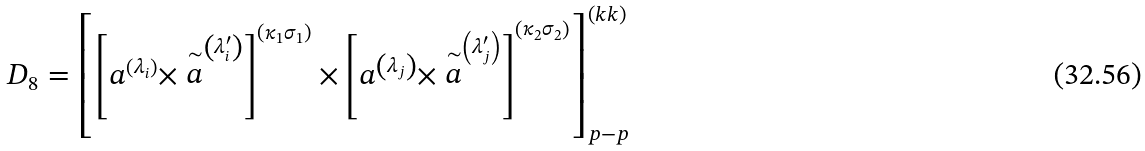<formula> <loc_0><loc_0><loc_500><loc_500>D _ { 8 } = \left [ \left [ a ^ { \left ( \lambda _ { i } \right ) } \times \stackrel { \sim } { a } ^ { \left ( \lambda _ { i } ^ { \prime } \right ) } \right ] ^ { \left ( \kappa _ { 1 } \sigma _ { 1 } \right ) } \times \left [ a ^ { \left ( \lambda _ { j } \right ) } \times \stackrel { \sim } { a } ^ { \left ( \lambda _ { j } ^ { \prime } \right ) } \right ] ^ { \left ( \kappa _ { 2 } \sigma _ { 2 } \right ) } \right ] _ { p - p } ^ { \left ( k k \right ) }</formula> 